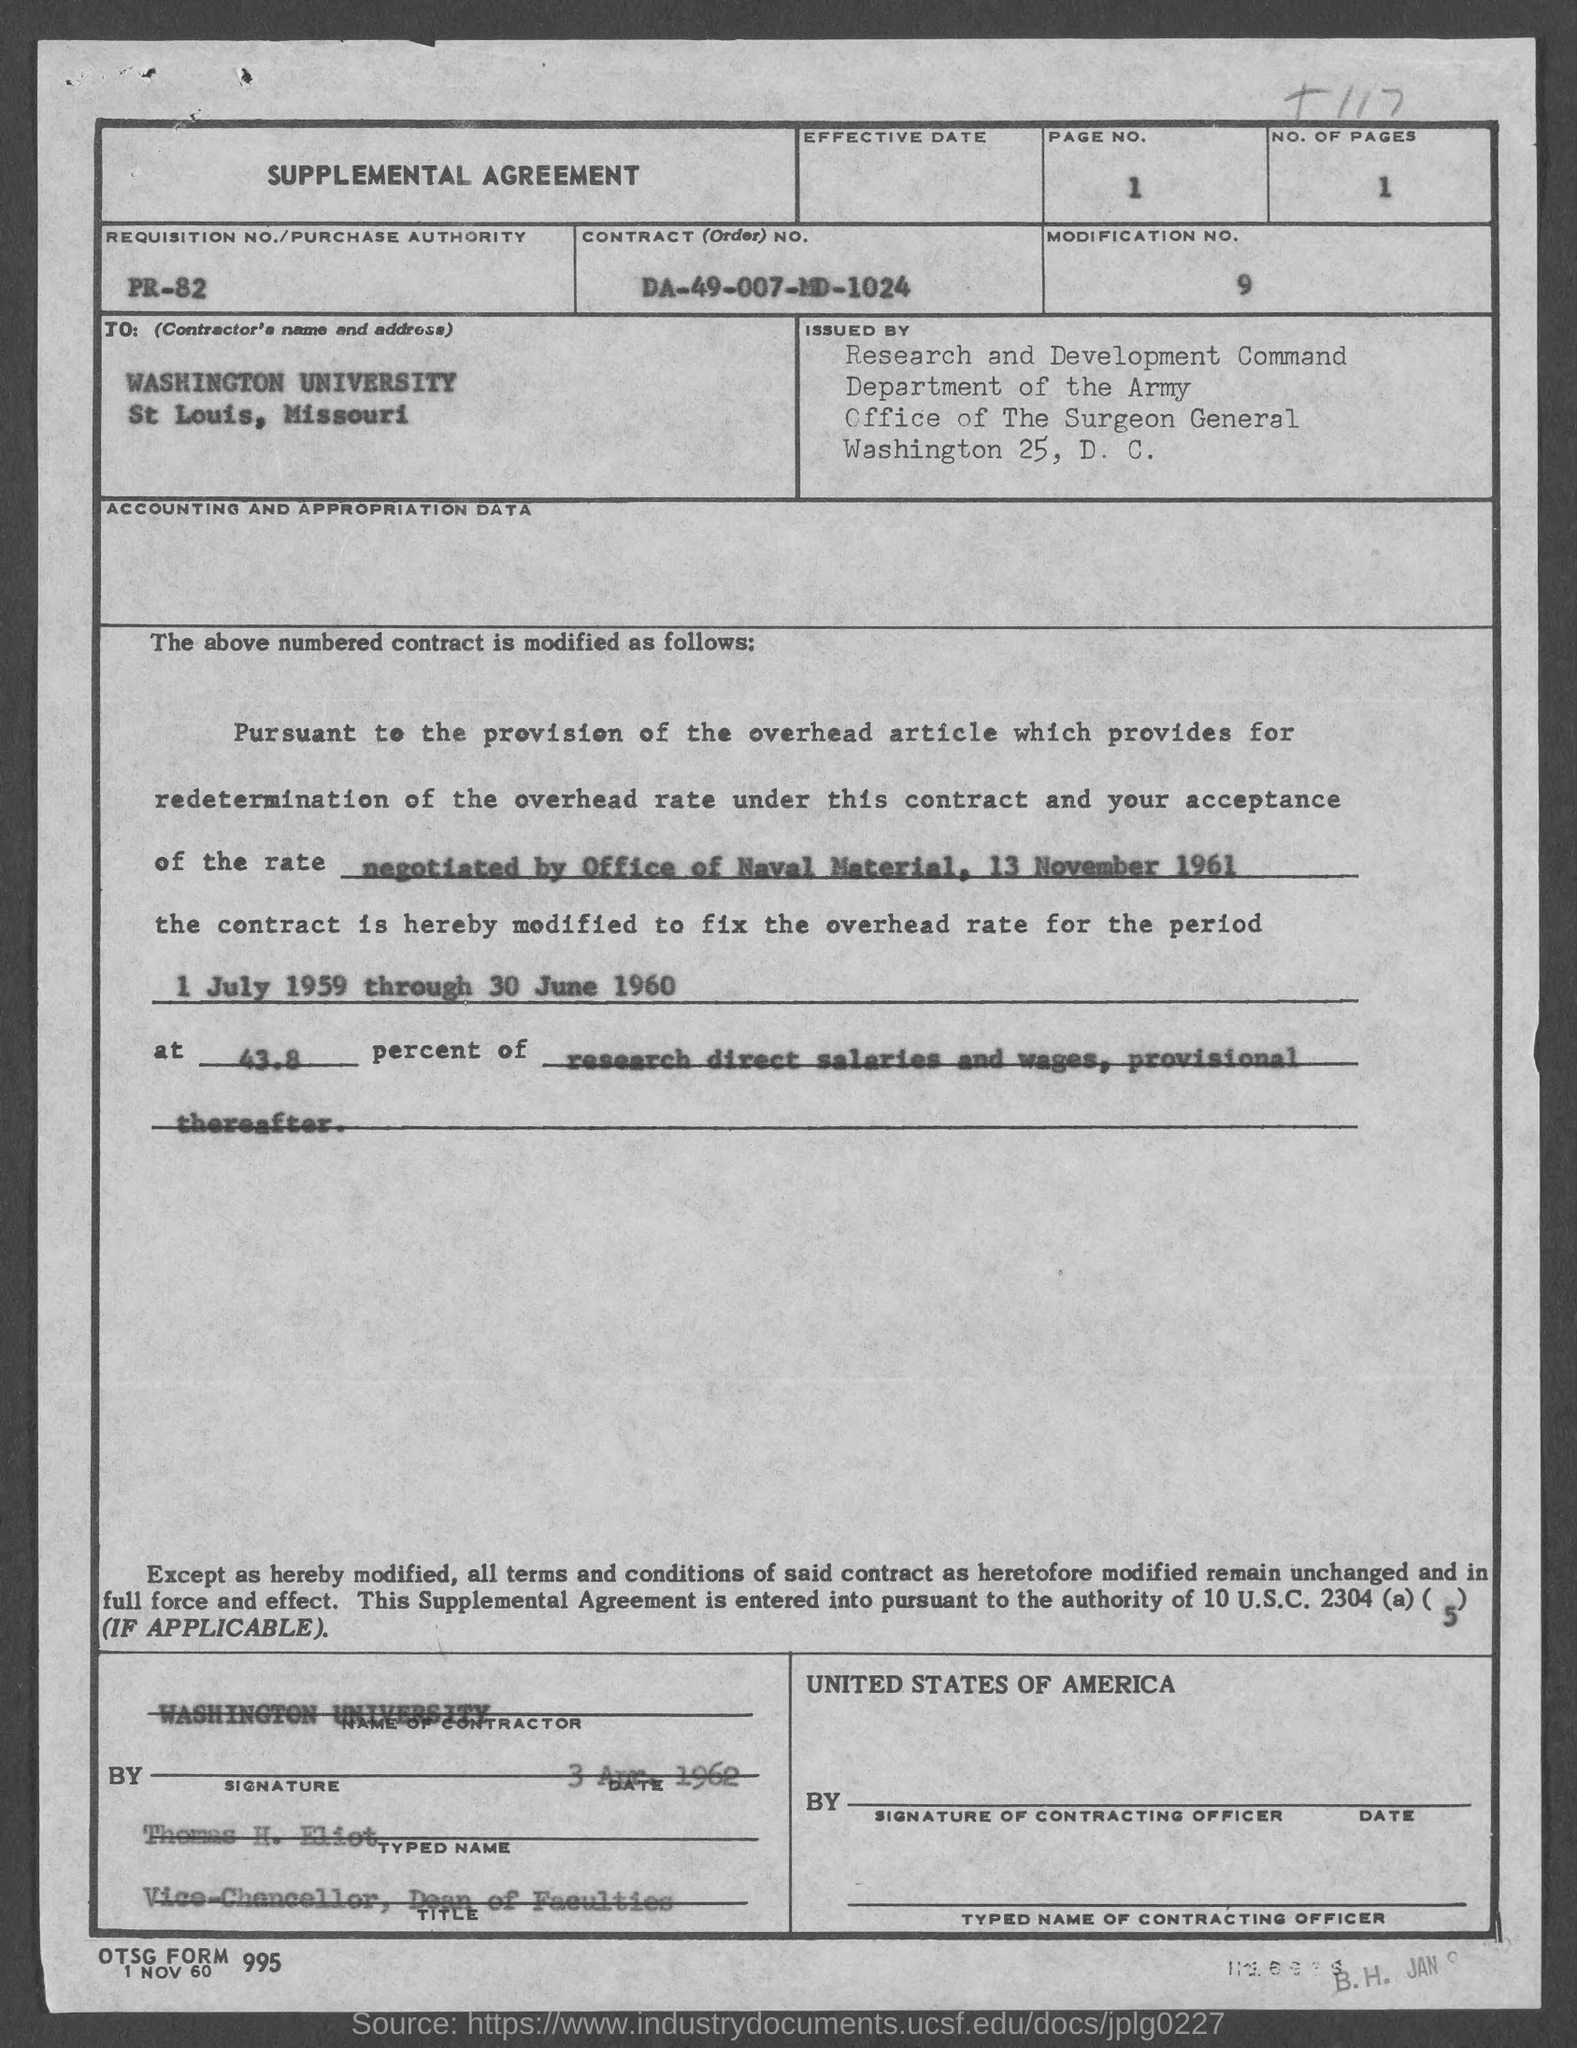What is the page no.?
Your answer should be compact. 1. What is the no. of pages ?
Offer a very short reply. 1. What is the modification no.?
Provide a short and direct response. 9. What is the contract (order) no.?
Offer a terse response. DA-49-007-MD-1024. What is the requisition no./ purchase authority ?
Provide a short and direct response. PR-82. What is the date below otsg form?
Provide a succinct answer. 1 Nov 60. What is the name of the contractor ?
Provide a short and direct response. Washington university. What is the position of thomas h. eliot ?
Give a very brief answer. Vice- Chancellor. 